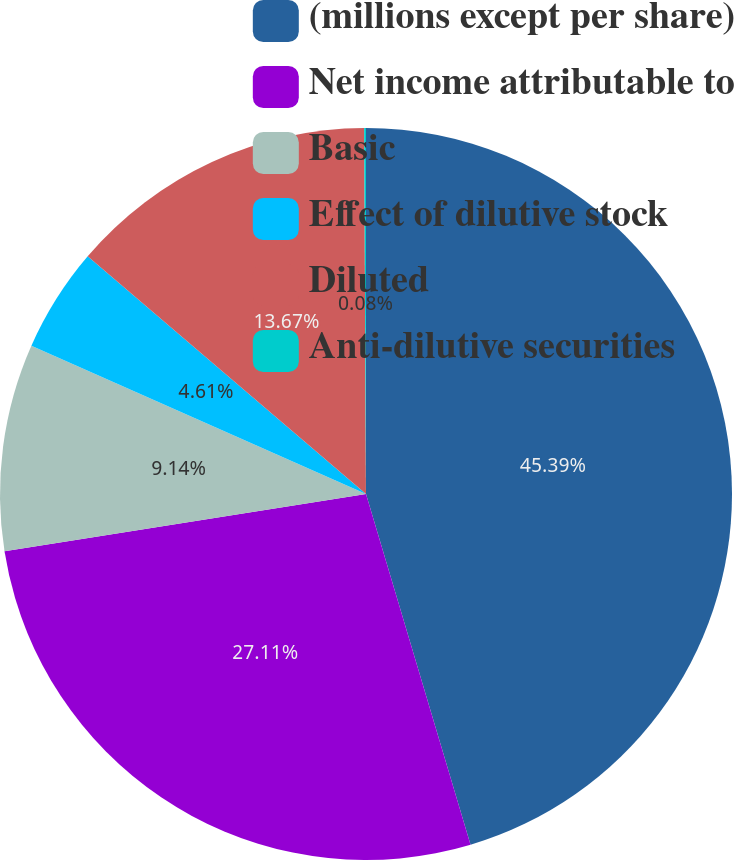Convert chart to OTSL. <chart><loc_0><loc_0><loc_500><loc_500><pie_chart><fcel>(millions except per share)<fcel>Net income attributable to<fcel>Basic<fcel>Effect of dilutive stock<fcel>Diluted<fcel>Anti-dilutive securities<nl><fcel>45.39%<fcel>27.11%<fcel>9.14%<fcel>4.61%<fcel>13.67%<fcel>0.08%<nl></chart> 